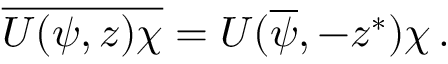Convert formula to latex. <formula><loc_0><loc_0><loc_500><loc_500>\overline { U ( \psi , z ) \chi } = U ( \overline { \psi } , - z ^ { \ast } ) \chi \, .</formula> 